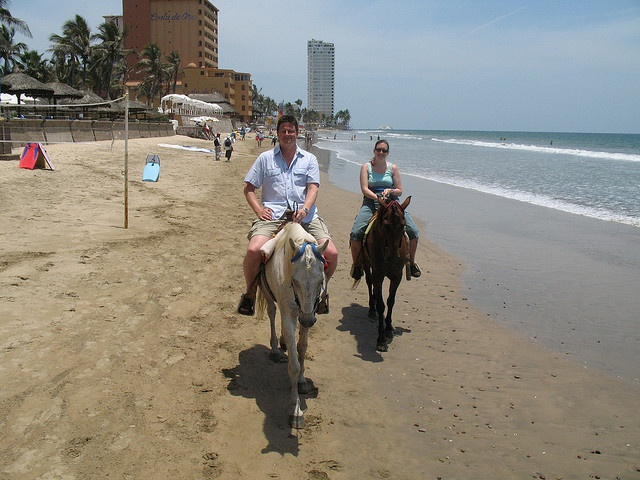Describe the objects in this image and their specific colors. I can see horse in black and gray tones, people in black, lavender, darkgray, and gray tones, people in black, gray, darkgray, and maroon tones, surfboard in black, lightblue, and gray tones, and people in black, gray, and darkgray tones in this image. 